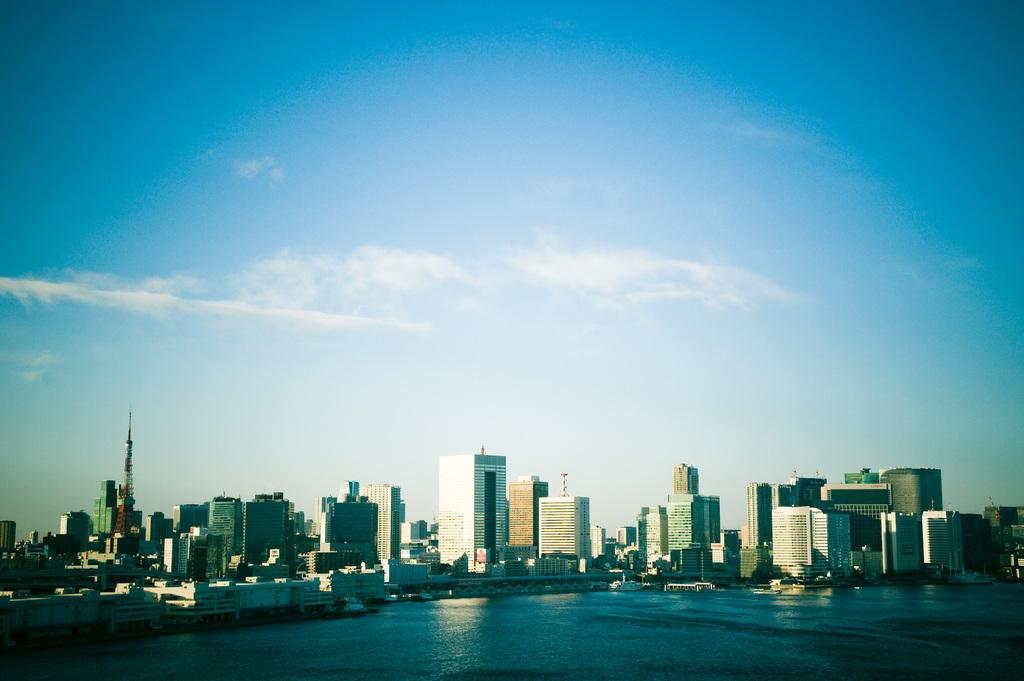What is the primary element visible in the image? There is water in the image. What can be seen in the distance behind the water? There are buildings in the background of the image. What else is visible in the background of the image? The sky is visible in the background of the image. How many crows are perched on the tallest building in the image? There are no crows visible in the image. What type of wilderness can be seen in the background of the image? There is no wilderness present in the image; it features water, buildings, and the sky. 